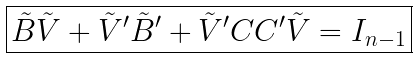Convert formula to latex. <formula><loc_0><loc_0><loc_500><loc_500>\boxed { \tilde { B } \tilde { V } + \tilde { V } ^ { \prime } \tilde { B } ^ { \prime } + \tilde { V } ^ { \prime } C C ^ { \prime } \tilde { V } = I _ { n - 1 } }</formula> 